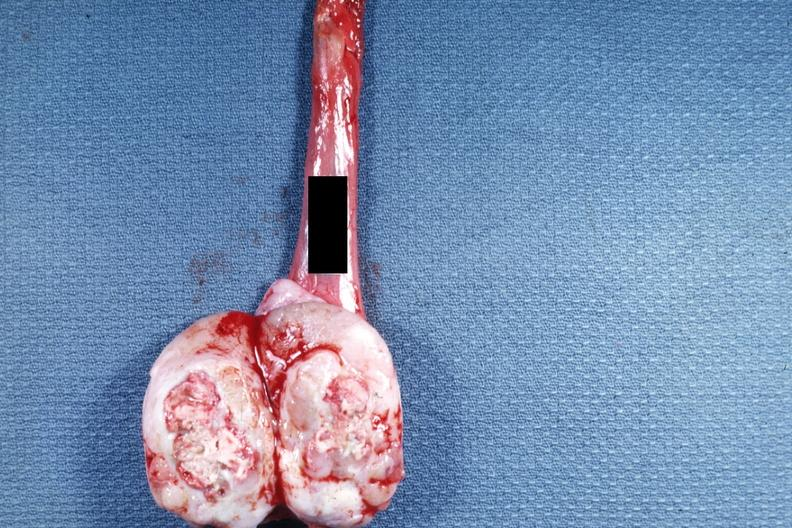does this image show tumor mass with a large amount of necrosis?
Answer the question using a single word or phrase. Yes 